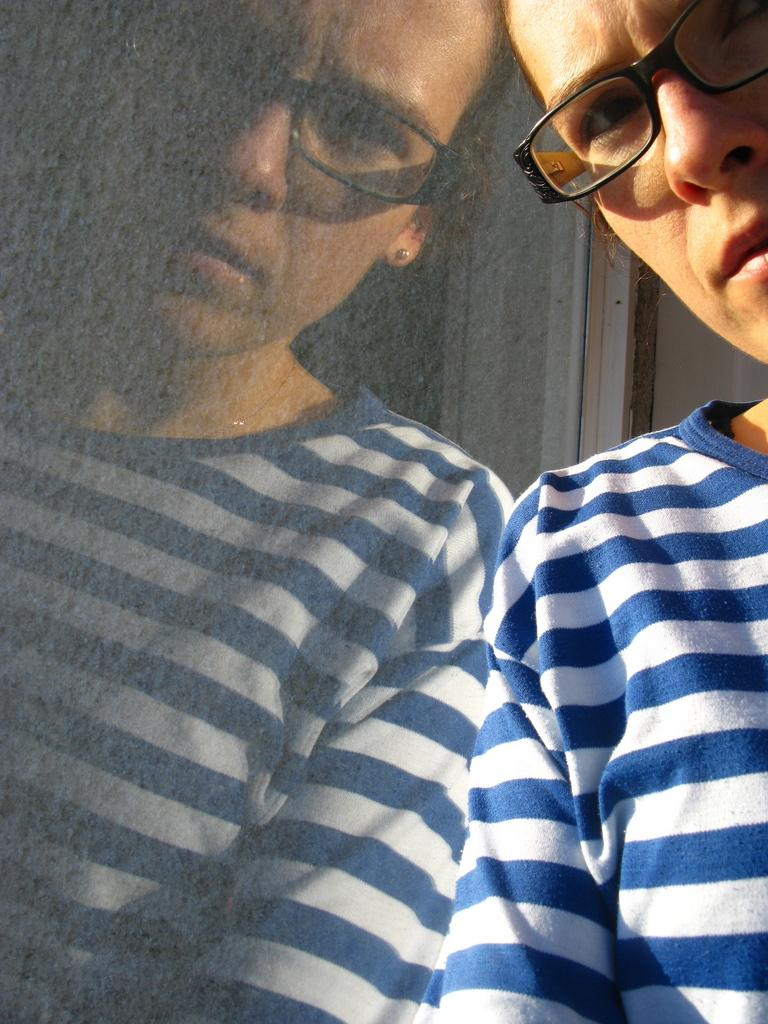What is the main subject of the image? The main subject of the image is a reflection of a woman. What accessories is the woman wearing in the image? The woman is wearing spectacles and earrings in the image. What type of clothing is the woman wearing in the image? The woman is wearing a t-shirt in the image. What architectural feature is visible in the image? There is a window visible in the image. How many ducks are visible on top of the woman's head in the image? There are no ducks visible on top of the woman's head in the image. What type of wheel can be seen in the image? There is no wheel present in the image. 